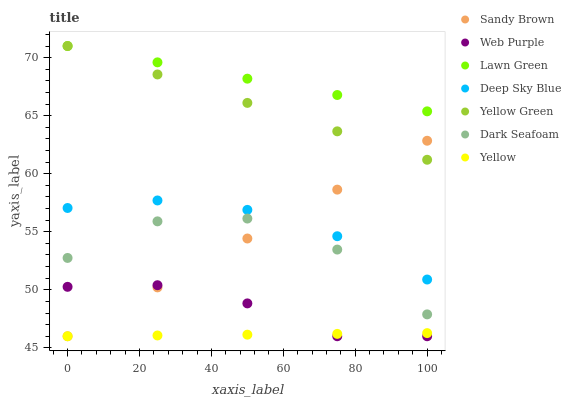Does Yellow have the minimum area under the curve?
Answer yes or no. Yes. Does Lawn Green have the maximum area under the curve?
Answer yes or no. Yes. Does Yellow Green have the minimum area under the curve?
Answer yes or no. No. Does Yellow Green have the maximum area under the curve?
Answer yes or no. No. Is Sandy Brown the smoothest?
Answer yes or no. Yes. Is Dark Seafoam the roughest?
Answer yes or no. Yes. Is Yellow Green the smoothest?
Answer yes or no. No. Is Yellow Green the roughest?
Answer yes or no. No. Does Web Purple have the lowest value?
Answer yes or no. Yes. Does Yellow Green have the lowest value?
Answer yes or no. No. Does Yellow Green have the highest value?
Answer yes or no. Yes. Does Web Purple have the highest value?
Answer yes or no. No. Is Yellow less than Deep Sky Blue?
Answer yes or no. Yes. Is Yellow Green greater than Deep Sky Blue?
Answer yes or no. Yes. Does Sandy Brown intersect Yellow Green?
Answer yes or no. Yes. Is Sandy Brown less than Yellow Green?
Answer yes or no. No. Is Sandy Brown greater than Yellow Green?
Answer yes or no. No. Does Yellow intersect Deep Sky Blue?
Answer yes or no. No. 